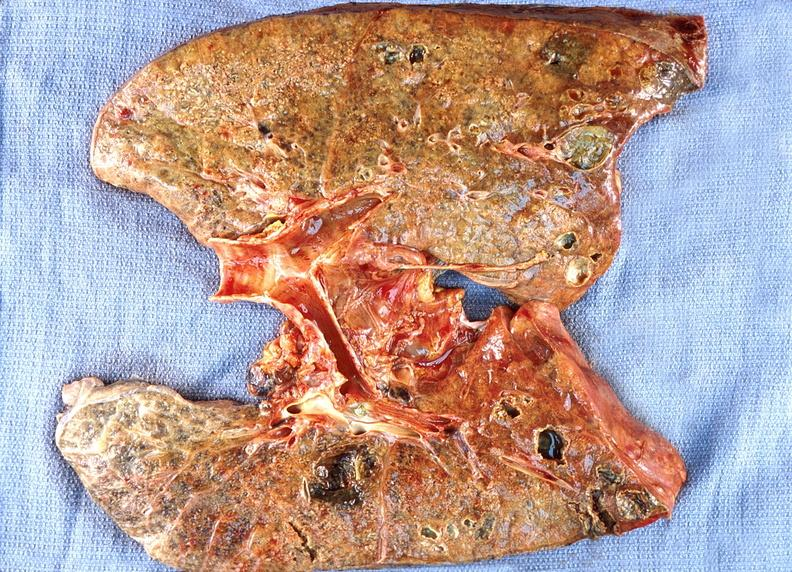does supernumerary digits show lung abscess?
Answer the question using a single word or phrase. No 